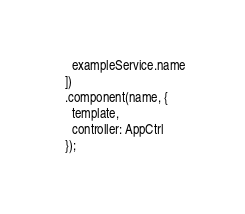Convert code to text. <code><loc_0><loc_0><loc_500><loc_500><_JavaScript_>    exampleService.name
  ])
  .component(name, {
    template,
    controller: AppCtrl
  });
</code> 